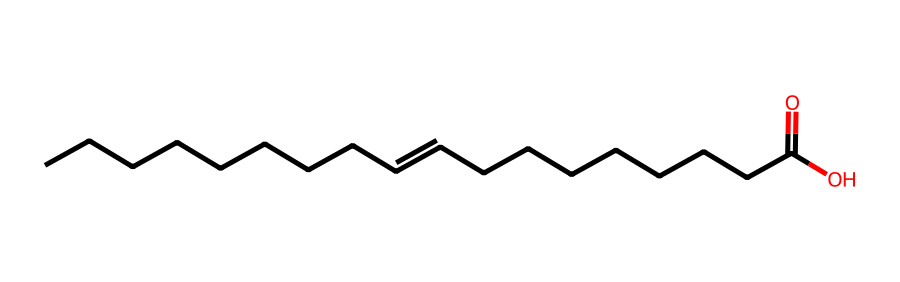What is the molecular formula of the compound represented? By analyzing the SMILES representation, I can determine the number of carbon (C), hydrogen (H), and oxygen (O) atoms. The structure indicates there are 18 carbon atoms, 34 hydrogen atoms, and 2 oxygen atoms. Therefore, the molecular formula is C18H34O2.
Answer: C18H34O2 How many double bonds are present in this structure? The SMILES notation features a double bond indicated by the "=" sign. By examining the representation, I see there is one double bond in the fatty acid chain.
Answer: 1 What type of isomerism does this compound exhibit? Given the presence of the cis double bond in the fatty acid, which allows for geometric (cis-trans) isomerism, I can confirm that this compound exhibits cis-trans isomerism specifically.
Answer: cis-trans What is the common name of this fat if it has a cis configuration? Considering that in the cis configuration this fatty acid is typically found in nature, it is known commonly as oleic acid.
Answer: oleic acid What is the common name of this fat if it has a trans configuration? When the structure exhibits trans configuration due to hydrogen atoms being positioned across from each other around the double bond, it is commonly referred to as elaidic acid.
Answer: elaidic acid How many total hydrogen atoms would be present if this were a saturated compound? In a saturated compound, each carbon atom would ideally be connected to enough hydrogen atoms to fulfill carbon's tetravalency (4 bonds total). For a fully saturated fatty acid with 18 carbons, the maximum number would be 36 hydrogens.
Answer: 36 What effect does the geometric isomerism have on the physical properties of the fatty acids? Cis and trans isomers differ in their spatial arrangements, which significantly impacts their physical properties like melting point and boiling point. The cis configuration typically has a lower melting point due to less efficient packing, while the trans configuration packs more closely, leading to a higher melting point.
Answer: physical properties 